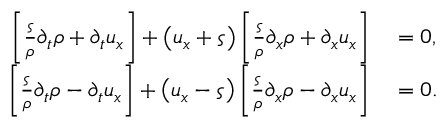Convert formula to latex. <formula><loc_0><loc_0><loc_500><loc_500>\begin{array} { r l } { \left [ \frac { \varsigma } { \rho } \partial _ { t } \rho + \partial _ { t } u _ { x } \right ] + \left ( u _ { x } + \varsigma \right ) \left [ \frac { \varsigma } { \rho } \partial _ { x } \rho + \partial _ { x } u _ { x } \right ] } & = 0 , } \\ { \left [ \frac { \varsigma } { \rho } \partial _ { t } \rho - \partial _ { t } u _ { x } \right ] + \left ( u _ { x } - \varsigma \right ) \left [ \frac { \varsigma } { \rho } \partial _ { x } \rho - \partial _ { x } u _ { x } \right ] } & = 0 . } \end{array}</formula> 